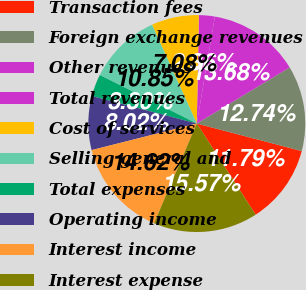Convert chart to OTSL. <chart><loc_0><loc_0><loc_500><loc_500><pie_chart><fcel>Transaction fees<fcel>Foreign exchange revenues<fcel>Other revenues<fcel>Total revenues<fcel>Cost of services<fcel>Selling general and<fcel>Total expenses<fcel>Operating income<fcel>Interest income<fcel>Interest expense<nl><fcel>11.79%<fcel>12.74%<fcel>13.68%<fcel>2.36%<fcel>7.08%<fcel>10.85%<fcel>3.3%<fcel>8.02%<fcel>14.62%<fcel>15.57%<nl></chart> 